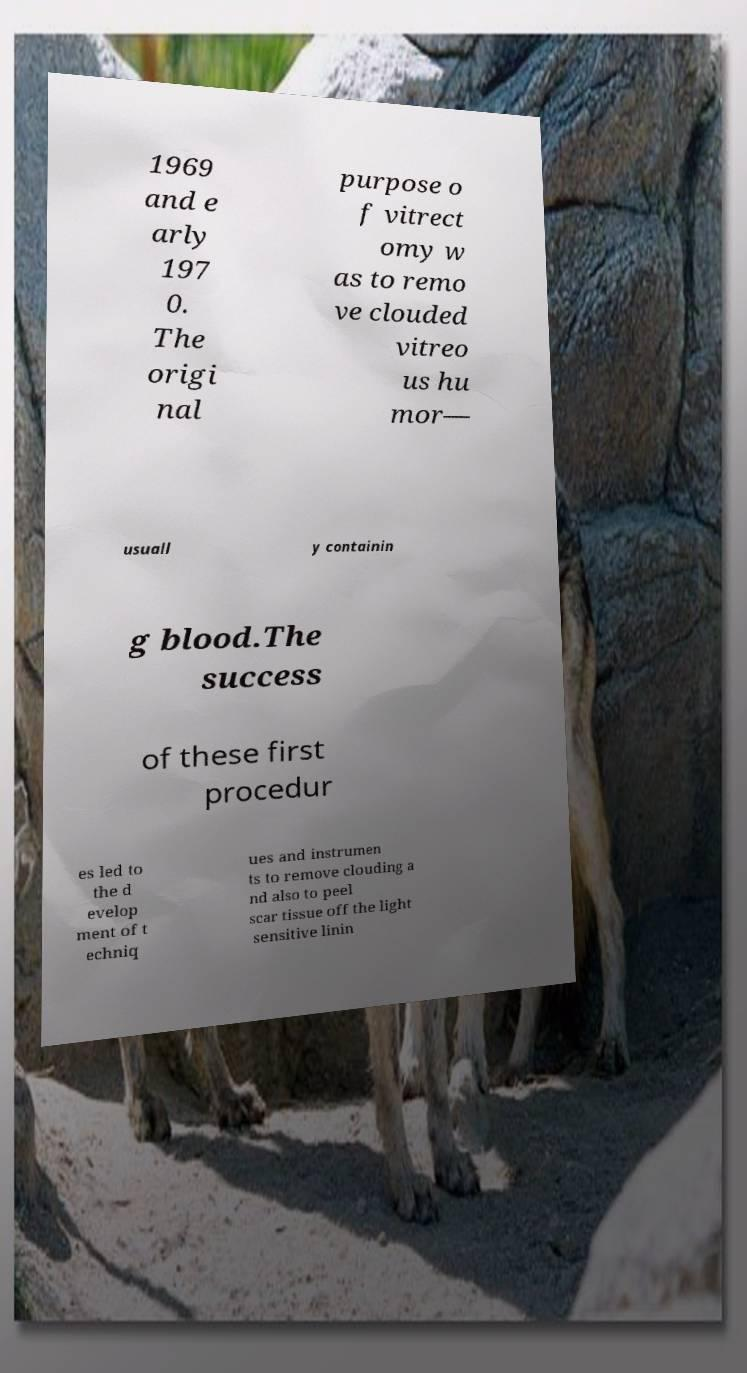Could you extract and type out the text from this image? 1969 and e arly 197 0. The origi nal purpose o f vitrect omy w as to remo ve clouded vitreo us hu mor— usuall y containin g blood.The success of these first procedur es led to the d evelop ment of t echniq ues and instrumen ts to remove clouding a nd also to peel scar tissue off the light sensitive linin 